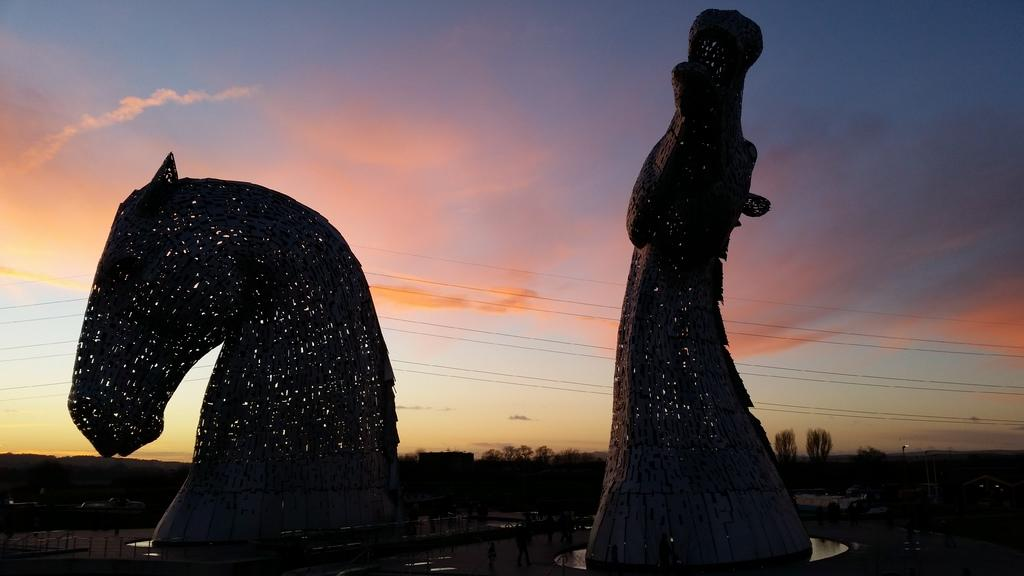What can be seen on the ground in the image? There are sculptures on the ground in the image. What is surrounding the sculptures? There is a fencing around the sculptures. What type of natural elements are visible in the background of the image? There are trees in the background of the image. What is visible at the top of the image? The sky is visible at the top of the image. How many cats can be seen climbing the sculptures in the image? There are no cats present in the image; it features sculptures surrounded by fencing. What type of mint is growing near the trees in the image? There is no mint visible in the image; it only features trees in the background. 